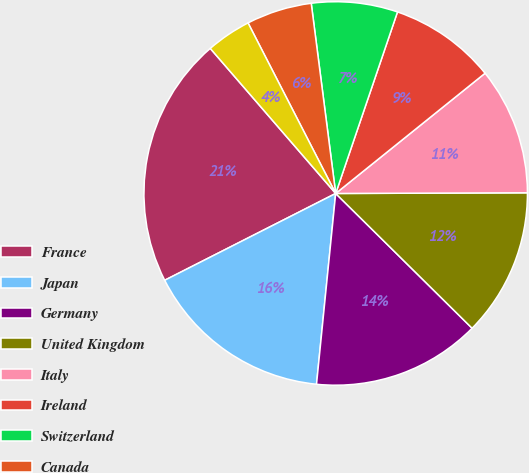<chart> <loc_0><loc_0><loc_500><loc_500><pie_chart><fcel>France<fcel>Japan<fcel>Germany<fcel>United Kingdom<fcel>Italy<fcel>Ireland<fcel>Switzerland<fcel>Canada<fcel>Australia<nl><fcel>21.13%<fcel>15.93%<fcel>14.19%<fcel>12.46%<fcel>10.73%<fcel>8.99%<fcel>7.26%<fcel>5.52%<fcel>3.79%<nl></chart> 